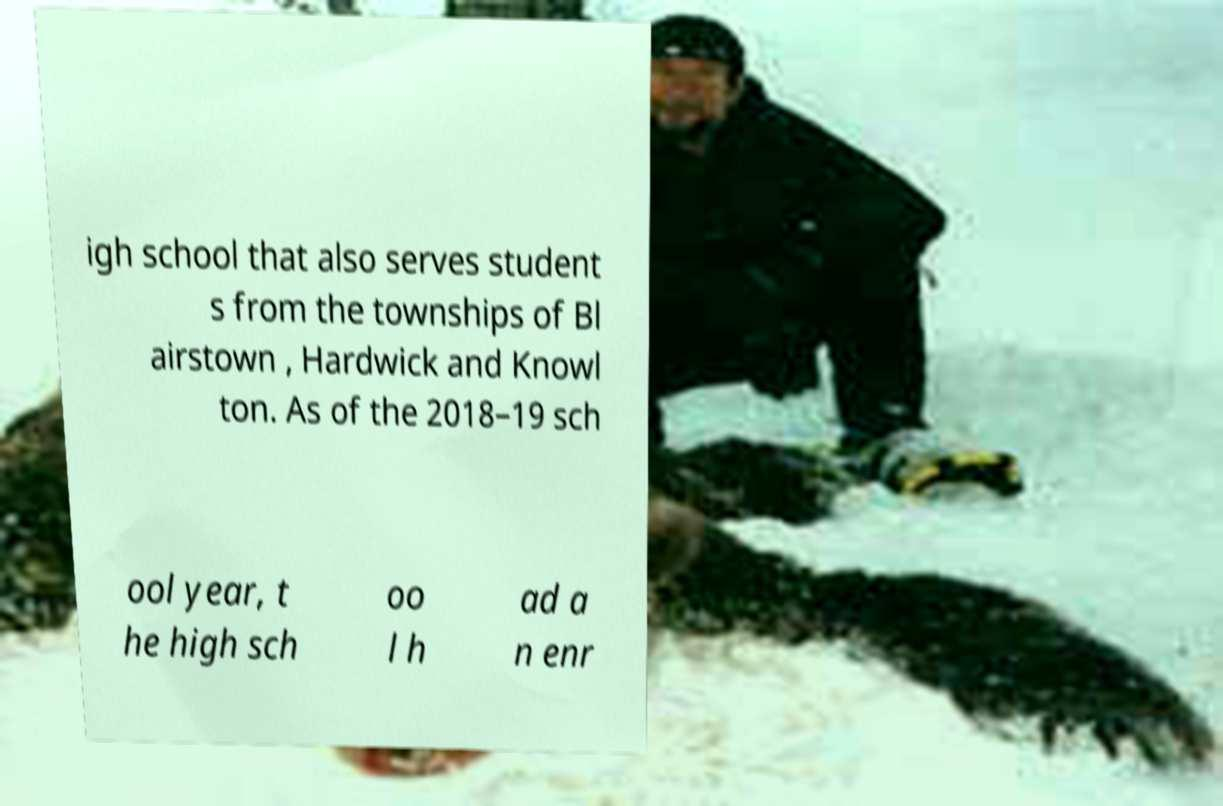What messages or text are displayed in this image? I need them in a readable, typed format. igh school that also serves student s from the townships of Bl airstown , Hardwick and Knowl ton. As of the 2018–19 sch ool year, t he high sch oo l h ad a n enr 